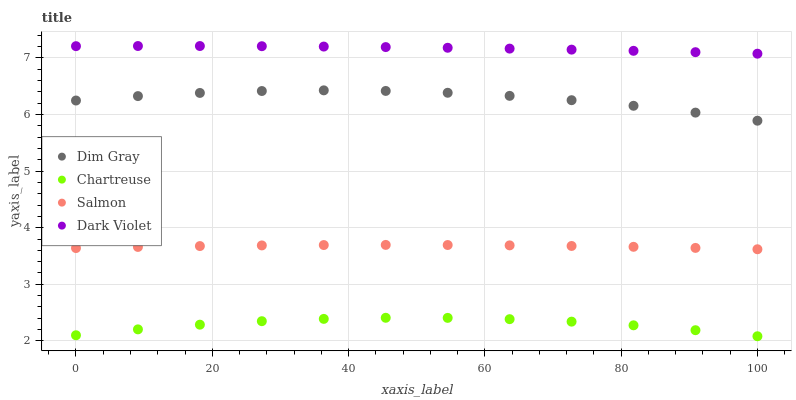Does Chartreuse have the minimum area under the curve?
Answer yes or no. Yes. Does Dark Violet have the maximum area under the curve?
Answer yes or no. Yes. Does Dim Gray have the minimum area under the curve?
Answer yes or no. No. Does Dim Gray have the maximum area under the curve?
Answer yes or no. No. Is Dark Violet the smoothest?
Answer yes or no. Yes. Is Dim Gray the roughest?
Answer yes or no. Yes. Is Salmon the smoothest?
Answer yes or no. No. Is Salmon the roughest?
Answer yes or no. No. Does Chartreuse have the lowest value?
Answer yes or no. Yes. Does Dim Gray have the lowest value?
Answer yes or no. No. Does Dark Violet have the highest value?
Answer yes or no. Yes. Does Dim Gray have the highest value?
Answer yes or no. No. Is Dim Gray less than Dark Violet?
Answer yes or no. Yes. Is Dim Gray greater than Salmon?
Answer yes or no. Yes. Does Dim Gray intersect Dark Violet?
Answer yes or no. No. 